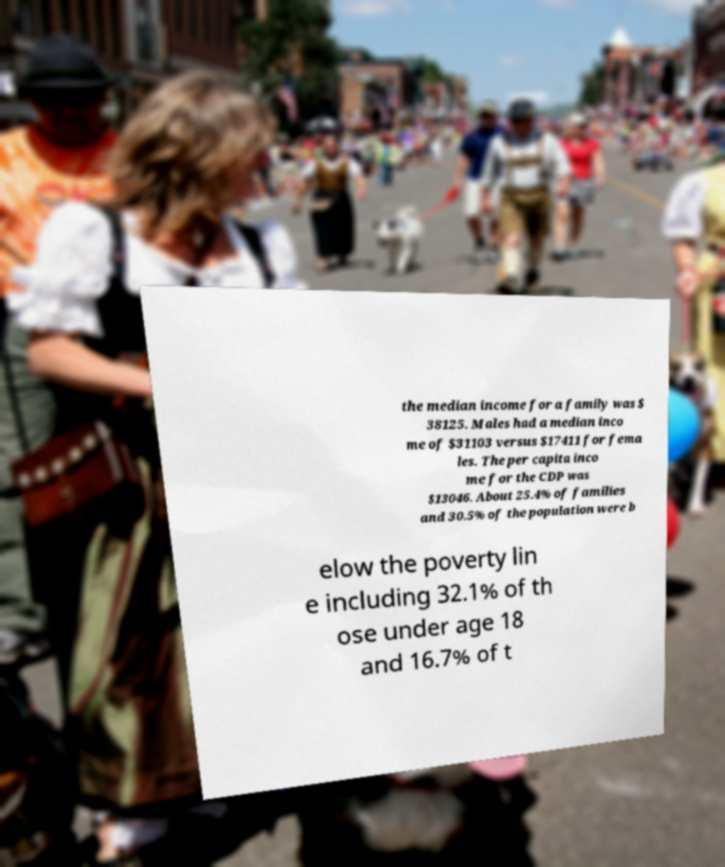What messages or text are displayed in this image? I need them in a readable, typed format. the median income for a family was $ 38125. Males had a median inco me of $31103 versus $17411 for fema les. The per capita inco me for the CDP was $13046. About 25.4% of families and 30.5% of the population were b elow the poverty lin e including 32.1% of th ose under age 18 and 16.7% of t 